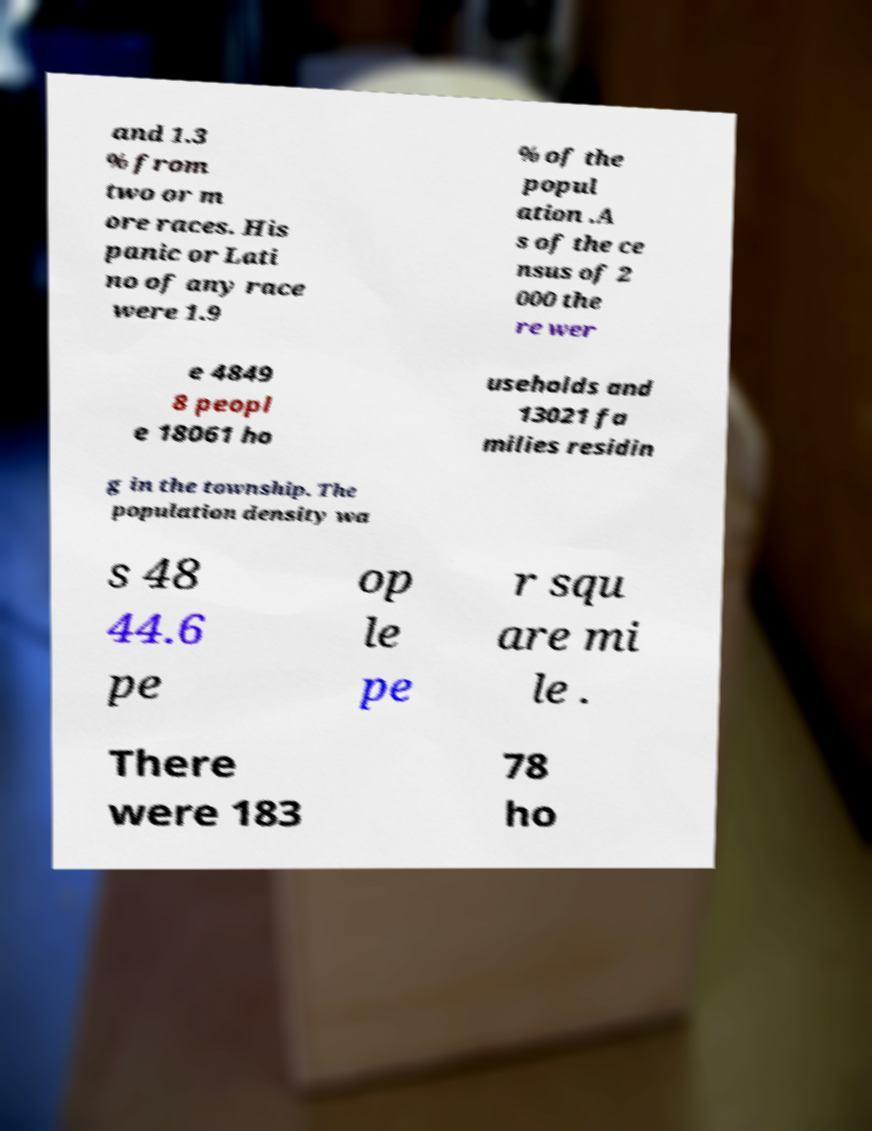Can you read and provide the text displayed in the image?This photo seems to have some interesting text. Can you extract and type it out for me? and 1.3 % from two or m ore races. His panic or Lati no of any race were 1.9 % of the popul ation .A s of the ce nsus of 2 000 the re wer e 4849 8 peopl e 18061 ho useholds and 13021 fa milies residin g in the township. The population density wa s 48 44.6 pe op le pe r squ are mi le . There were 183 78 ho 